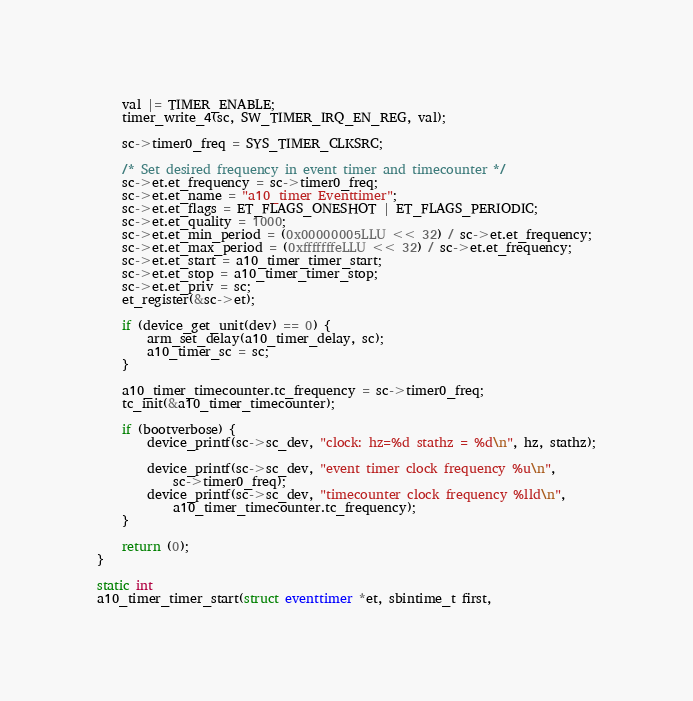Convert code to text. <code><loc_0><loc_0><loc_500><loc_500><_C_>	val |= TIMER_ENABLE;
	timer_write_4(sc, SW_TIMER_IRQ_EN_REG, val);

	sc->timer0_freq = SYS_TIMER_CLKSRC;

	/* Set desired frequency in event timer and timecounter */
	sc->et.et_frequency = sc->timer0_freq;
	sc->et.et_name = "a10_timer Eventtimer";
	sc->et.et_flags = ET_FLAGS_ONESHOT | ET_FLAGS_PERIODIC;
	sc->et.et_quality = 1000;
	sc->et.et_min_period = (0x00000005LLU << 32) / sc->et.et_frequency;
	sc->et.et_max_period = (0xfffffffeLLU << 32) / sc->et.et_frequency;
	sc->et.et_start = a10_timer_timer_start;
	sc->et.et_stop = a10_timer_timer_stop;
	sc->et.et_priv = sc;
	et_register(&sc->et);

	if (device_get_unit(dev) == 0) {
		arm_set_delay(a10_timer_delay, sc);
		a10_timer_sc = sc;
	}

	a10_timer_timecounter.tc_frequency = sc->timer0_freq;
	tc_init(&a10_timer_timecounter);

	if (bootverbose) {
		device_printf(sc->sc_dev, "clock: hz=%d stathz = %d\n", hz, stathz);

		device_printf(sc->sc_dev, "event timer clock frequency %u\n", 
		    sc->timer0_freq);
		device_printf(sc->sc_dev, "timecounter clock frequency %lld\n", 
		    a10_timer_timecounter.tc_frequency);
	}

	return (0);
}

static int
a10_timer_timer_start(struct eventtimer *et, sbintime_t first,</code> 